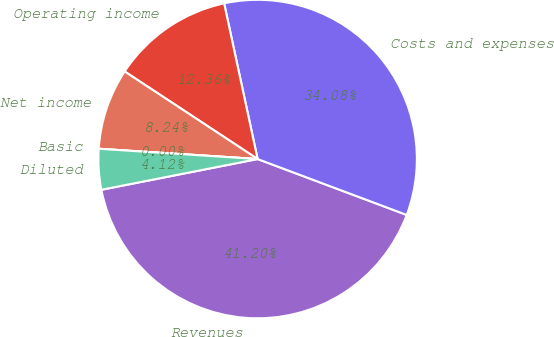<chart> <loc_0><loc_0><loc_500><loc_500><pie_chart><fcel>Revenues<fcel>Costs and expenses<fcel>Operating income<fcel>Net income<fcel>Basic<fcel>Diluted<nl><fcel>41.2%<fcel>34.08%<fcel>12.36%<fcel>8.24%<fcel>0.0%<fcel>4.12%<nl></chart> 